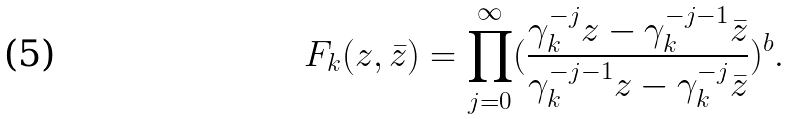Convert formula to latex. <formula><loc_0><loc_0><loc_500><loc_500>F _ { k } ( z , \bar { z } ) = \prod _ { j = 0 } ^ { \infty } ( \frac { \gamma _ { k } ^ { - j } z - \gamma _ { k } ^ { - j - 1 } \bar { z } } { \gamma _ { k } ^ { - j - 1 } z - \gamma _ { k } ^ { - j } \bar { z } } ) ^ { b } .</formula> 